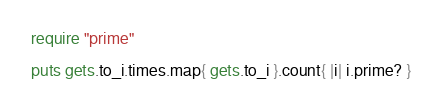Convert code to text. <code><loc_0><loc_0><loc_500><loc_500><_Ruby_>require "prime"

puts gets.to_i.times.map{ gets.to_i }.count{ |i| i.prime? }</code> 